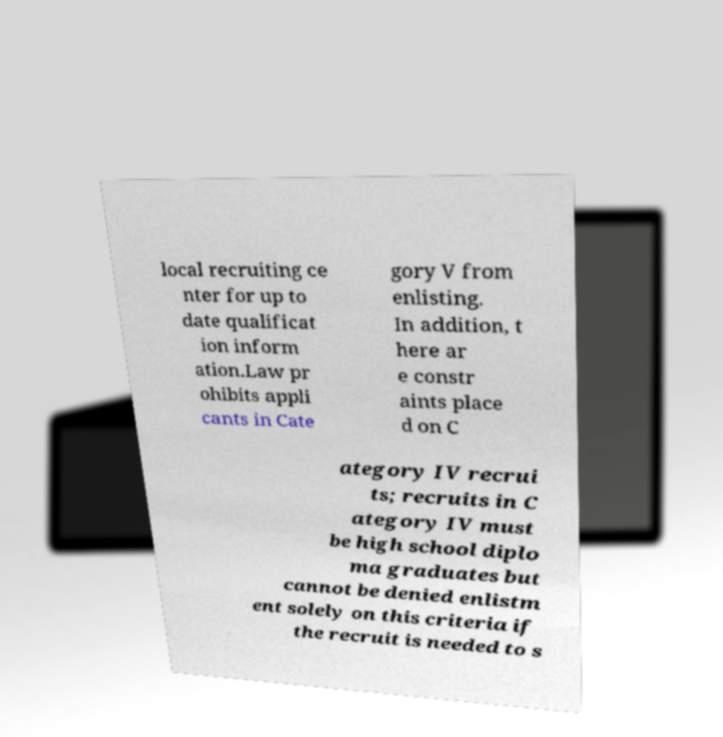Could you extract and type out the text from this image? local recruiting ce nter for up to date qualificat ion inform ation.Law pr ohibits appli cants in Cate gory V from enlisting. In addition, t here ar e constr aints place d on C ategory IV recrui ts; recruits in C ategory IV must be high school diplo ma graduates but cannot be denied enlistm ent solely on this criteria if the recruit is needed to s 